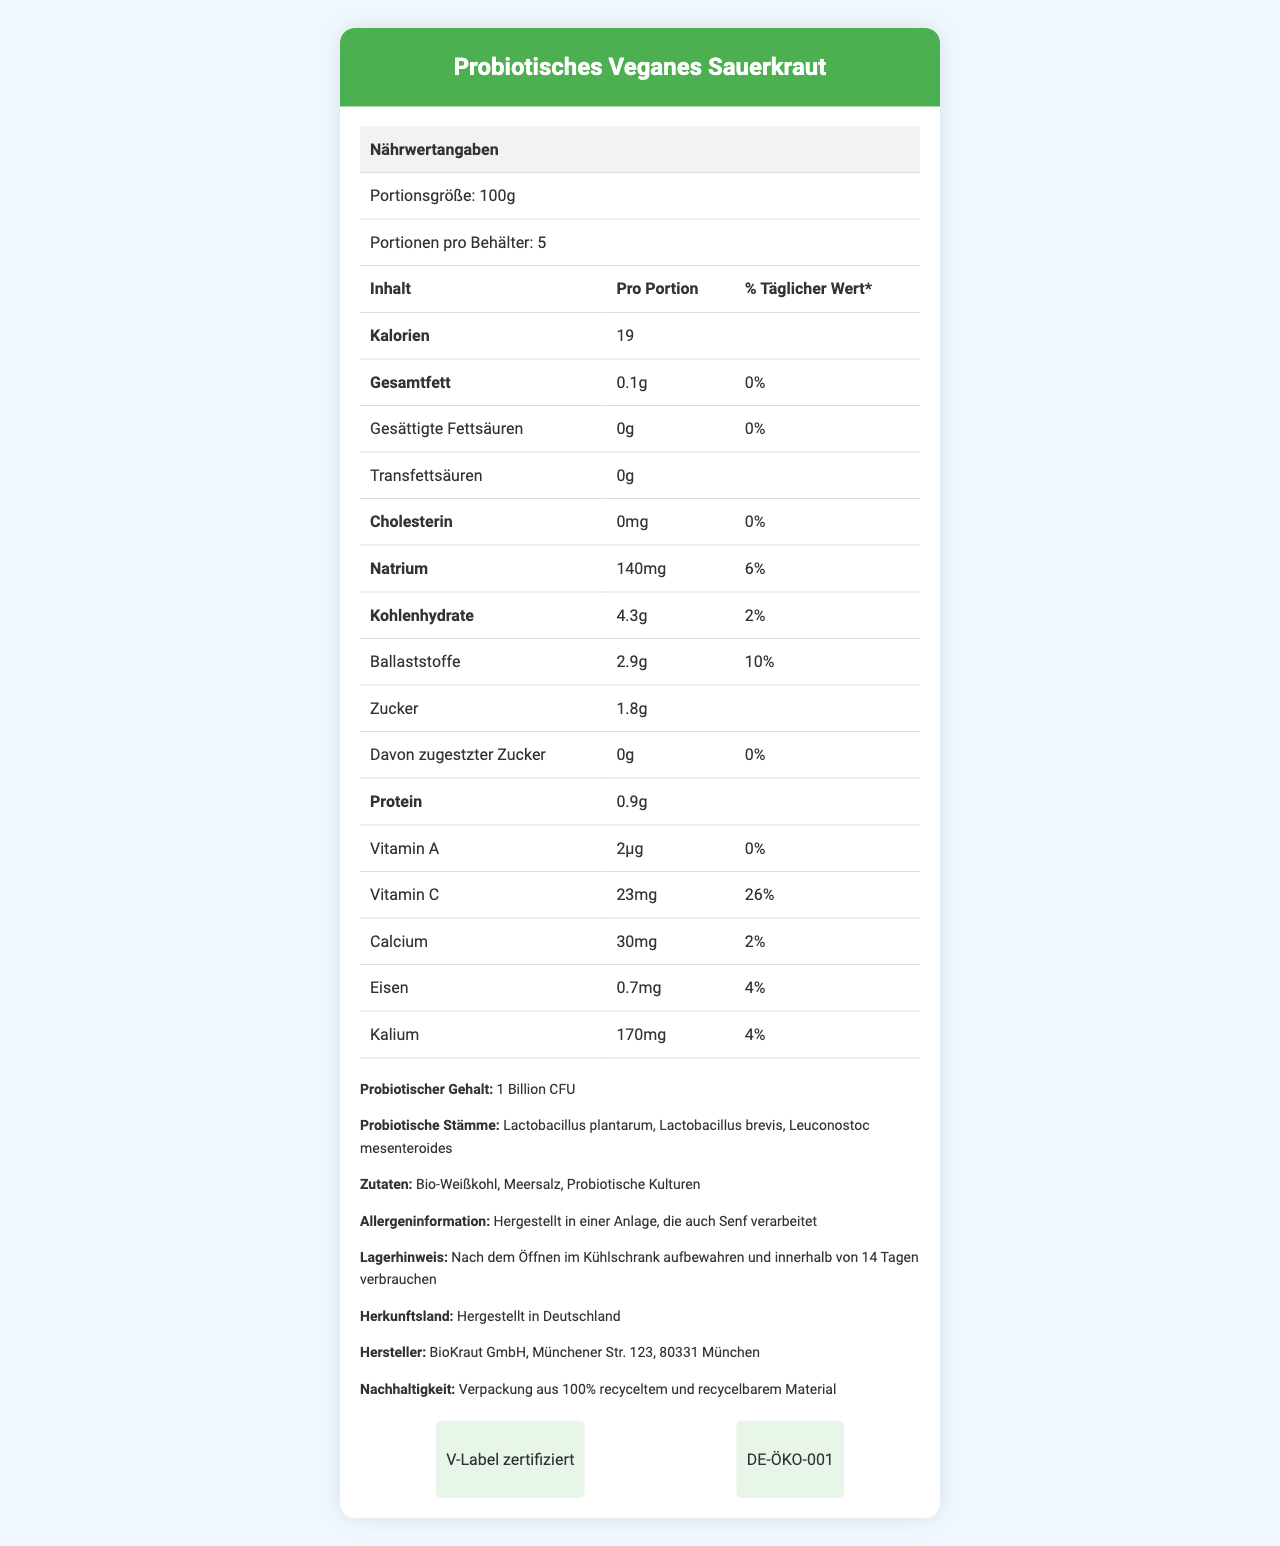what is the portion size? The portion size is listed as "100g" under the serving size section.
Answer: 100g how many servings are in one container? The document states that there are "5" servings per container.
Answer: 5 what is the total calorie count per serving? The calorie content per serving is listed as "19" calories.
Answer: 19 what is the daily value percentage of dietary fiber per serving? The document shows that the daily value percentage for dietary fiber per serving is "10%".
Answer: 10% what strains of probiotics are included in this product? The section on probiotic content lists the strains: "Lactobacillus plantarum, Lactobacillus brevis, and Leuconostoc mesenteroides".
Answer: Lactobacillus plantarum, Lactobacillus brevis, Leuconostoc mesenteroides how much sodium is in one serving? The sodium content per serving is listed as "140mg".
Answer: 140mg what percentage of the daily value for vitamin C does one serving provide? The document lists "26%" as the daily value percentage for vitamin C.
Answer: 26% which of the following ingredients is not present in the sauerkraut? A. Bio-Weißkohl B. Meersalz C. Added Sugars D. Probiotische Kulturen The listed ingredients include "Bio-Weißkohl", "Meersalz", and "Probiotische Kulturen". Added sugars are not mentioned.
Answer: C. Added Sugars what is the serving's total carbohydrate content? A. 2.9g B. 1.8g C. 4.3g D. 0.9g The total carbohydrate content per serving is listed as "4.3g".
Answer: C. 4.3g is this product vegan certified? The document states that this product has a "V-Label" vegan certification.
Answer: Yes summarize the main nutritional advantages of this product. The document highlights that the product is low in calories (19 per serving) and fat (0.1g total fat), provides a significant daily value of dietary fiber (10%), has a relatively low sodium content (140mg per serving), and contains 1 billion CFU of probiotics.
Answer: This product is low in calories and fat, provides a good amount of dietary fiber, has a low sodium content, and contains beneficial probiotics. can this product help meet daily protein requirements? The product has "0.9g" of protein per serving, which is quite low and does not significantly contribute to daily protein requirements.
Answer: No what is the manufacturing location of this product? The document states that the product is manufactured in Germany by "BioKraut GmbH" located in "Münchener Str. 123, 80331 München".
Answer: Hergestellt in Deutschland; BioKraut GmbH, Münchener Str. 123, 80331 München can we determine the amount of sugar added in the product from the document? The document clearly states that there are "0g" of added sugars.
Answer: Yes does the product contain any allergens? The document states that it is "Hergestellt in einer Anlage, die auch Senf verarbeitet", meaning made in a facility that also processes mustard.
Answer: Yes 